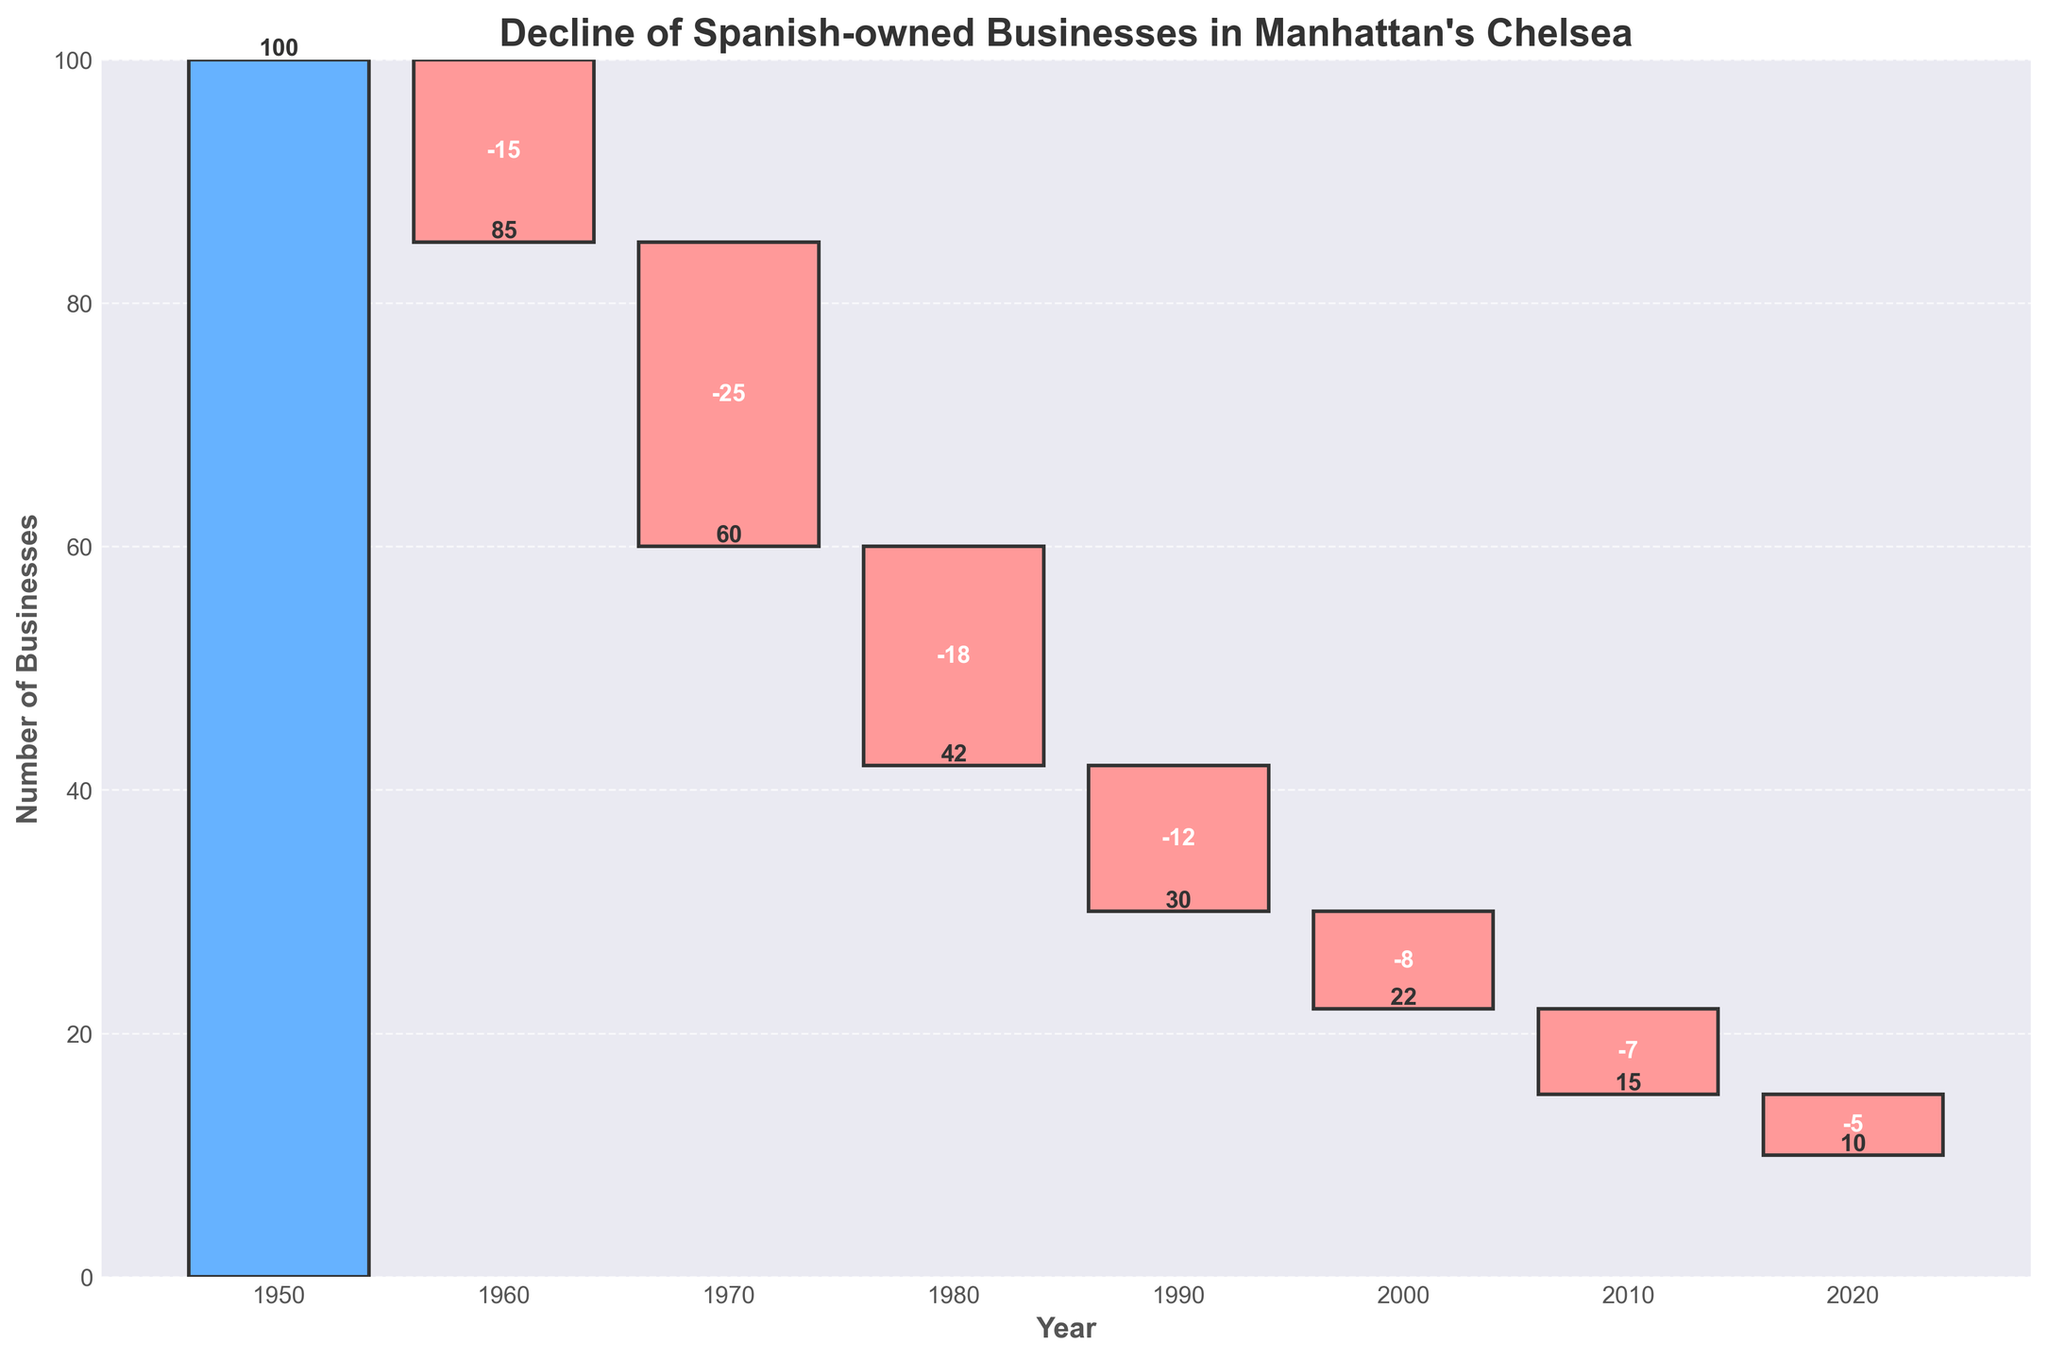1. What is the title of the chart? The title is usually displayed at the top of the figure. In this case, it's written in bold.
Answer: Decline of Spanish-owned Businesses in Manhattan's Chelsea 2. How many years are represented in the chart? Count each year mentioned on the x-axis. There are data points from 1950 to 2020.
Answer: 8 3. What color represents a decline in the number of businesses? Observe the color coding: negative values are typically represented by one color, distinct from positive values. Here, declines are marked with a reddish color.
Answer: Red 4. What was the cumulative number of businesses in 2000? Look at the number at the top of the bar labeled 2000.
Answer: 22 5. Between which two decades was the largest decline in businesses observed? Compare the change values for each decade and find the largest negative one.
Answer: Between 1960 and 1970 6. How much did the number of businesses decrease from 1950 to 2020? Subtract the cumulative number in 2020 from the cumulative number in 1950. Calculation: 100 - 10.
Answer: 90 7. By how much did the number of businesses decrease between 1970 and 1980? Look at the change value for the decade from 1970 to 1980.
Answer: 18 8. Which decade has the smallest decline in the number of businesses? Find the decade with the smallest negative change value.
Answer: 2010 to 2020 9. What was the cumulative number of businesses remaining in 1990? Identify the cumulative number on the 1990 bar.
Answer: 30 10. Compare the decline in businesses between the 1960s and 1980s. Which decade saw a greater decline? Compare the absolute changes: -25 for 1960s and -18 for 1980s. The 1960s saw a greater decline.
Answer: 1960s 